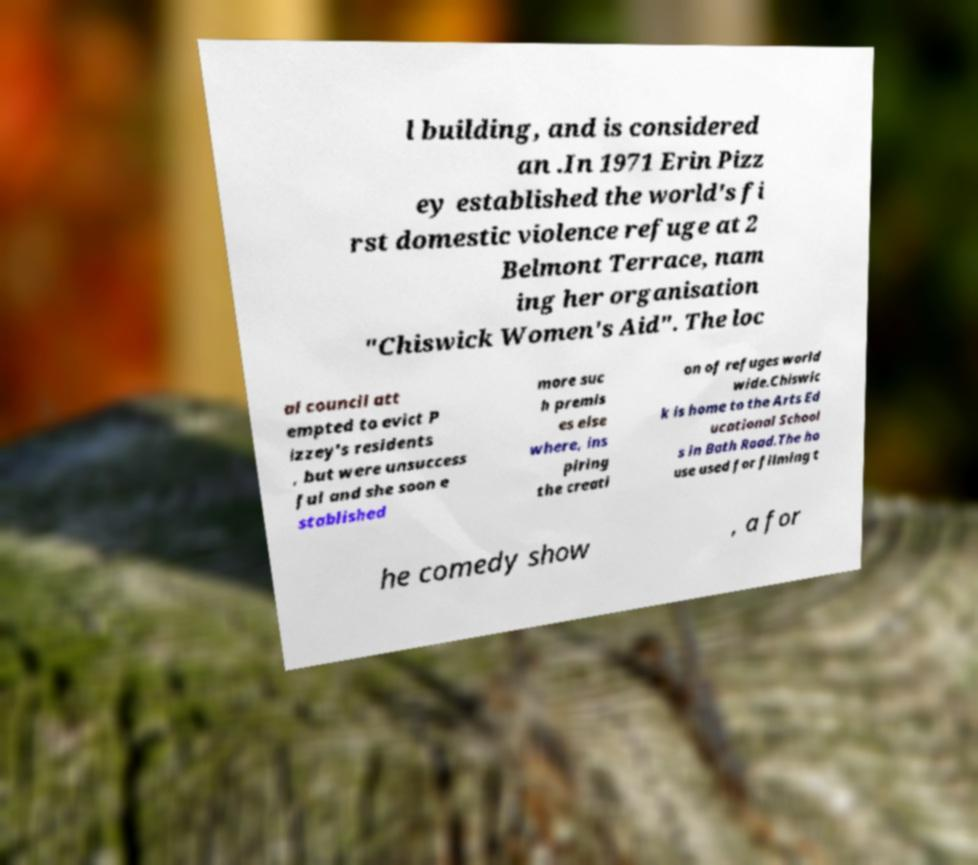Please identify and transcribe the text found in this image. l building, and is considered an .In 1971 Erin Pizz ey established the world's fi rst domestic violence refuge at 2 Belmont Terrace, nam ing her organisation "Chiswick Women's Aid". The loc al council att empted to evict P izzey's residents , but were unsuccess ful and she soon e stablished more suc h premis es else where, ins piring the creati on of refuges world wide.Chiswic k is home to the Arts Ed ucational School s in Bath Road.The ho use used for filming t he comedy show , a for 